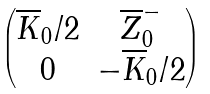Convert formula to latex. <formula><loc_0><loc_0><loc_500><loc_500>\begin{pmatrix} \overline { K } _ { 0 } / 2 & \overline { Z } _ { 0 } ^ { - } \\ 0 & - \overline { K } _ { 0 } / 2 \end{pmatrix}</formula> 